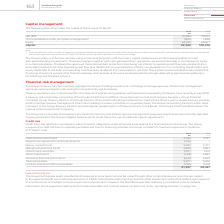From Vodafone Group Plc's financial document, Which financial years' information is shown in the table? The document shows two values: 2018 and 2019. From the document: "163 Vodafone Group Plc Annual Report 2019 2019 2018 €m €m Net debt 27,033 29,631 Financial liabilities under put option arrangements 1 1,844 1,838 Equ..." Also, How much is 2019 cash at bank and in hand ? According to the financial document, 2,434 (in millions). The relevant text states: "2019 2018 €m €m Cash at bank and in hand 2,434 2,197 Repurchase agreements and bank deposits 2,196 – Money market funds 9,007 2,477 Managed invest..." Also, How much is 2018 cash at bank and in hand ? According to the financial document, 2,197 (in millions). The relevant text states: "2019 2018 €m €m Cash at bank and in hand 2,434 2,197 Repurchase agreements and bank deposits 2,196 – Money market funds 9,007 2,477 Managed investment f..." Additionally, Between 2018 and 2019, which year had a greater amount of money market funds? According to the financial document, 2019. The relevant text states: "163 Vodafone Group Plc Annual Report 2019..." Additionally, Between 2018 and 2019, which year had a greater amount of managed investment funds? According to the financial document, 2019. The relevant text states: "163 Vodafone Group Plc Annual Report 2019..." Additionally, Between 2018 and 2019, which year had a greater amount of government securities? According to the financial document, 2019. The relevant text states: "163 Vodafone Group Plc Annual Report 2019..." 